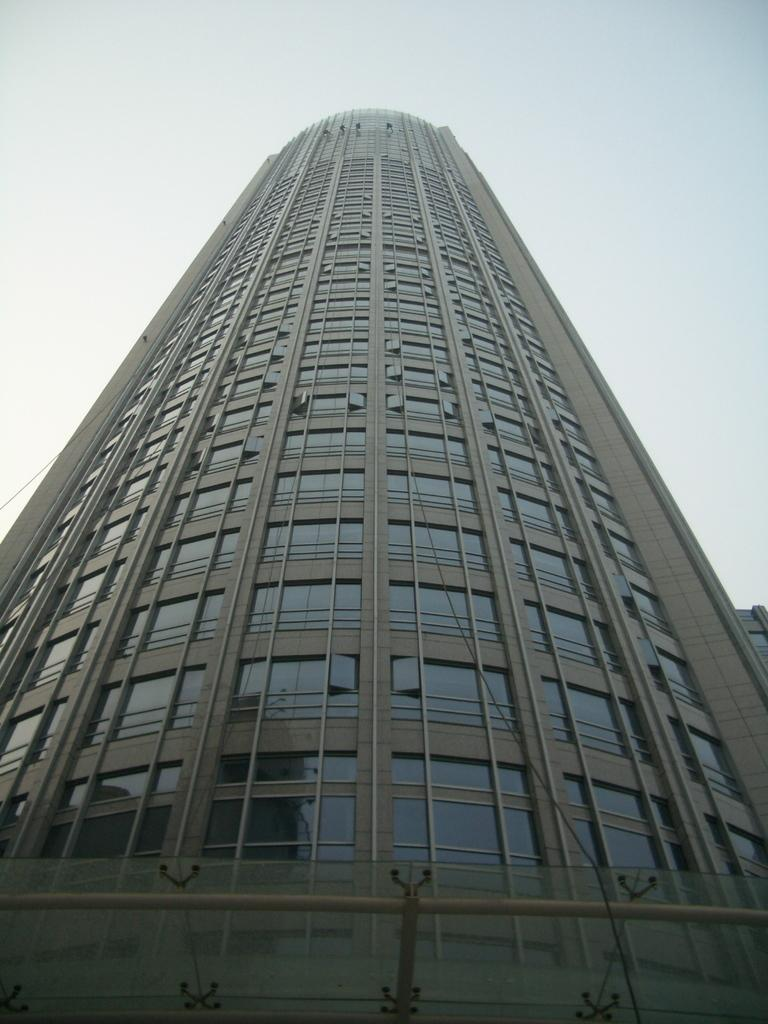What is the main structure in the picture? There is a building in the picture. What can be seen at the top of the picture? The sky is visible at the top of the picture. What feature of the building is mentioned in the facts? There are glasses (windows) on the building. How many cows can be seen grazing under the umbrella in the image? There are no cows or an umbrella in the image. 